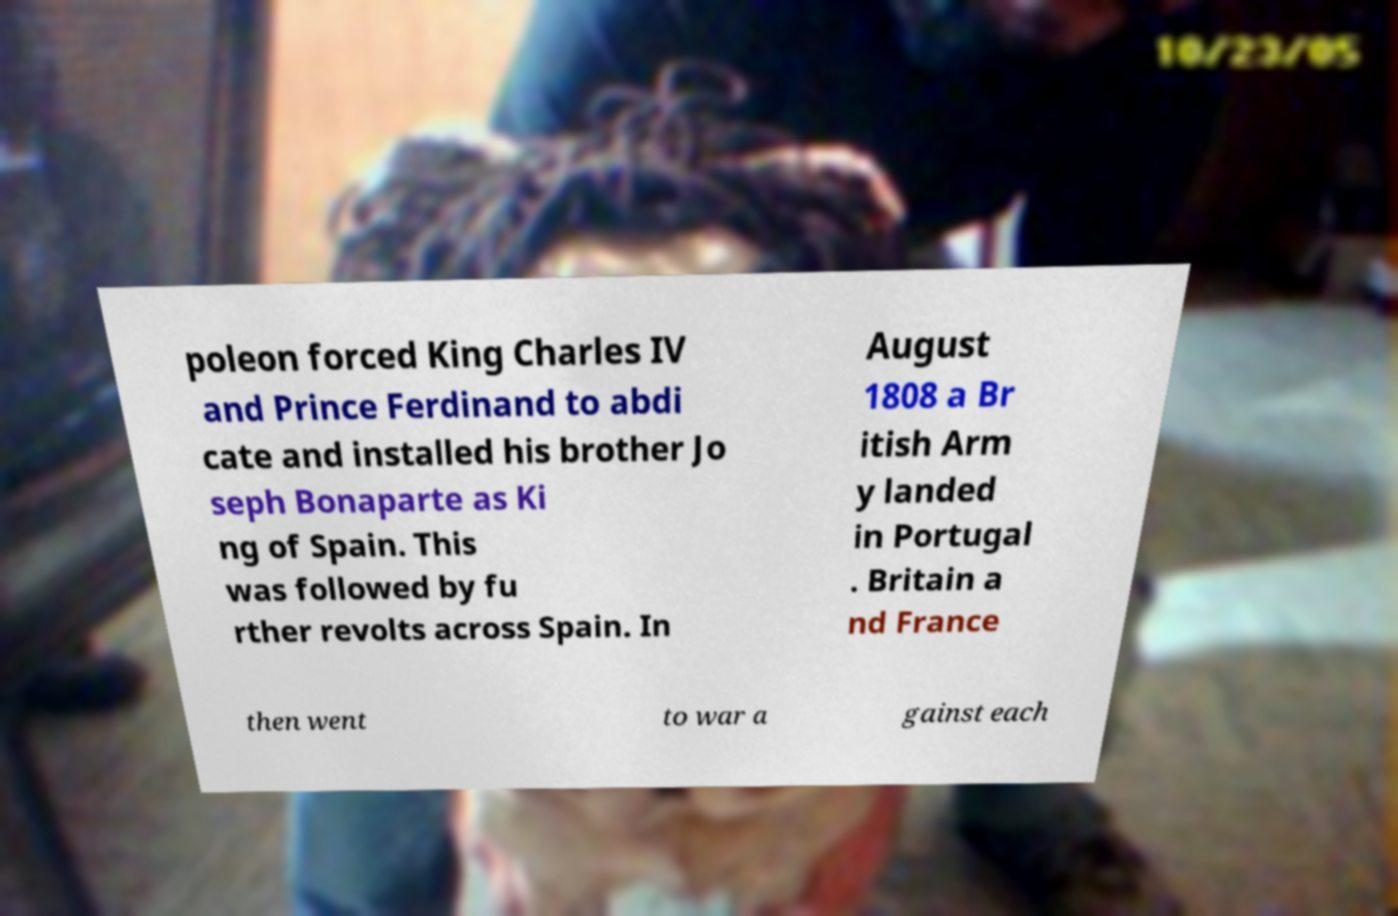For documentation purposes, I need the text within this image transcribed. Could you provide that? poleon forced King Charles IV and Prince Ferdinand to abdi cate and installed his brother Jo seph Bonaparte as Ki ng of Spain. This was followed by fu rther revolts across Spain. In August 1808 a Br itish Arm y landed in Portugal . Britain a nd France then went to war a gainst each 